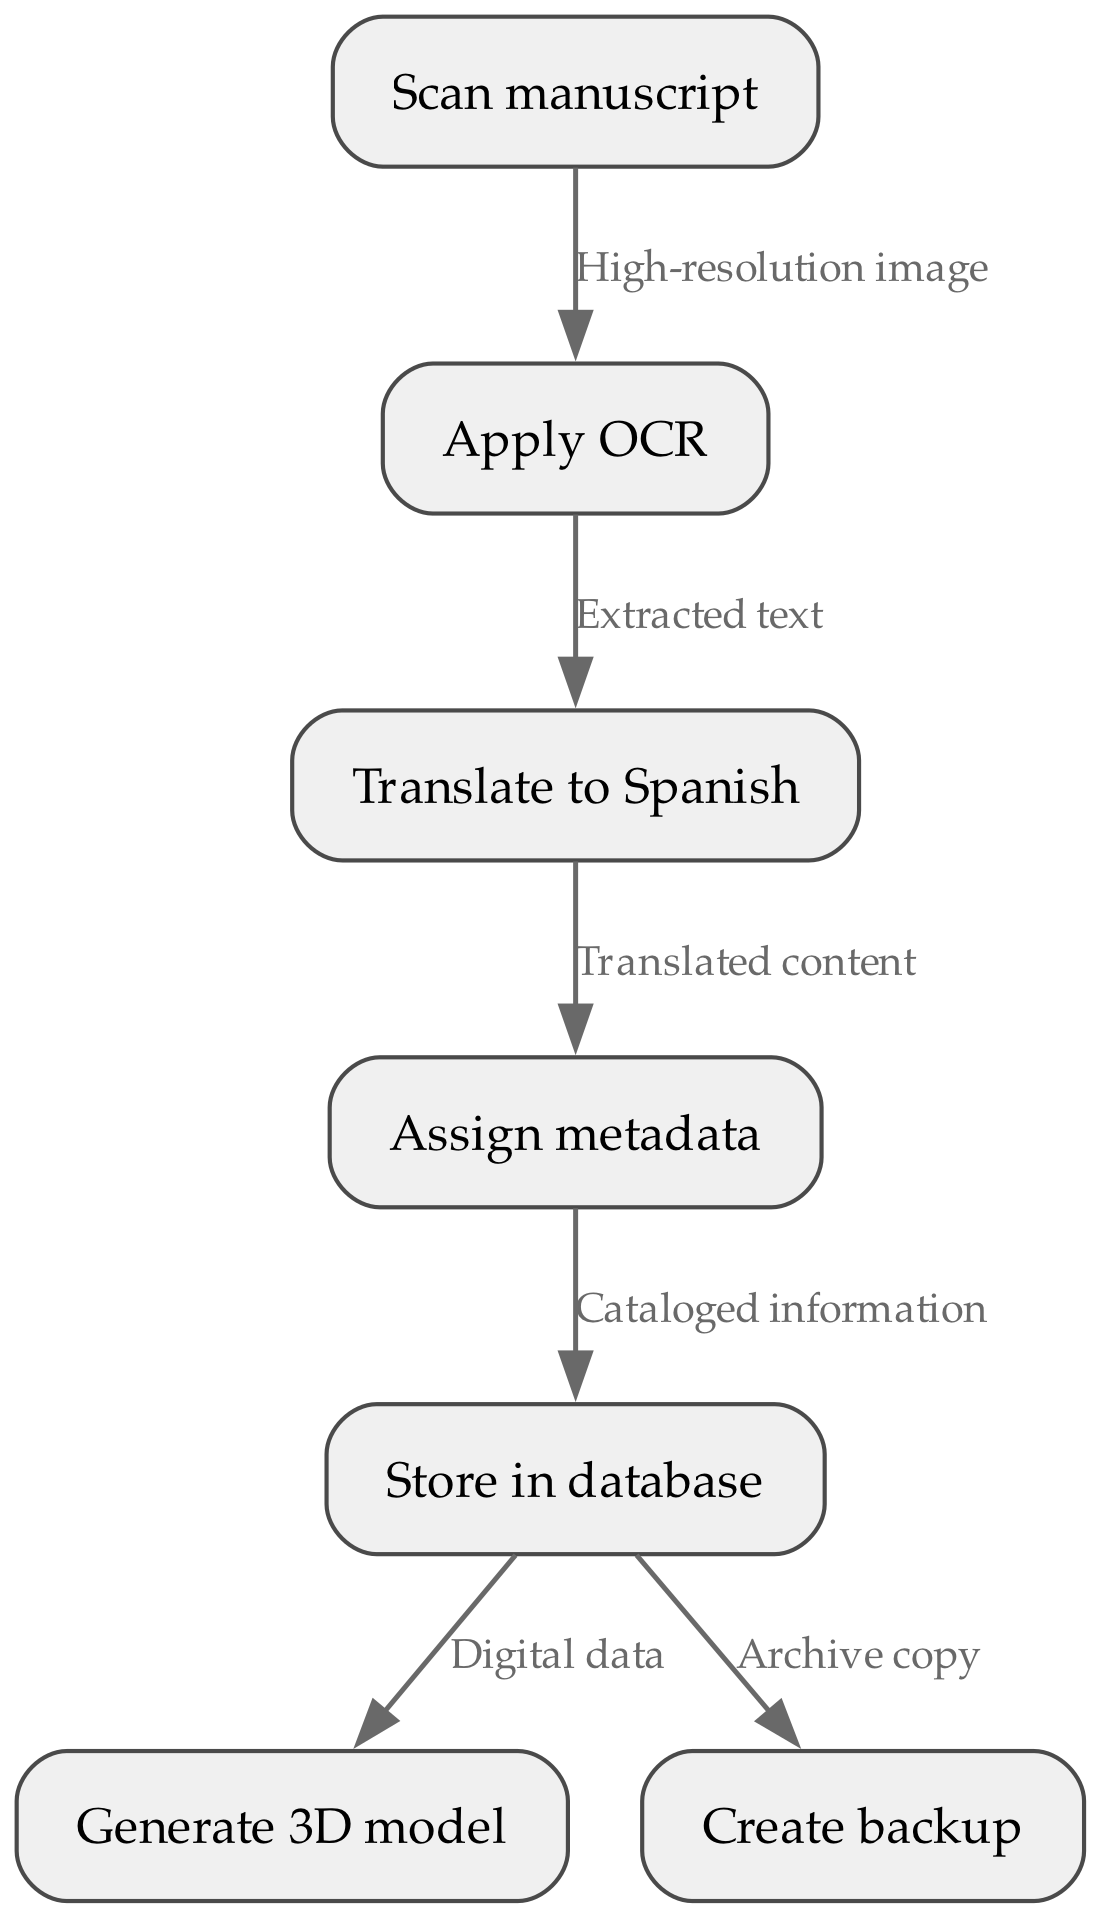What is the first step in the process? The first step in the flowchart is to "Scan manuscript," which is represented as the initial node.
Answer: Scan manuscript How many nodes are in the flowchart? Counting all the unique tasks represented in the nodes, there are seven nodes.
Answer: 7 What is the final action taken in the cataloging process? The last action in the flowchart is "Create backup." This is connected to the storage in the database.
Answer: Create backup What is the relationship between "Apply OCR" and "Translate to Spanish"? "Apply OCR" provides the "Extracted text," which is necessary to "Translate to Spanish." This signifies a direct flow from one task to the next.
Answer: Extracted text Which node does "Cataloged information" lead to? "Cataloged information" leads directly to the next step, which is "Store in database." This is indicated by a directed edge connecting these tasks.
Answer: Store in database How many edges are present in the flowchart? The flowchart has six edges, which represent the relationships between the tasks.
Answer: 6 What action precedes the step "Assign metadata"? The action that precedes "Assign metadata" is "Translate to Spanish," showing the sequence that needs to occur before metadata can be assigned.
Answer: Translate to Spanish Which task generates "Digital data"? The task that generates "Digital data" is "Store in database," indicating that this information is produced directly from storing the cataloged manuscripts.
Answer: Store in database 